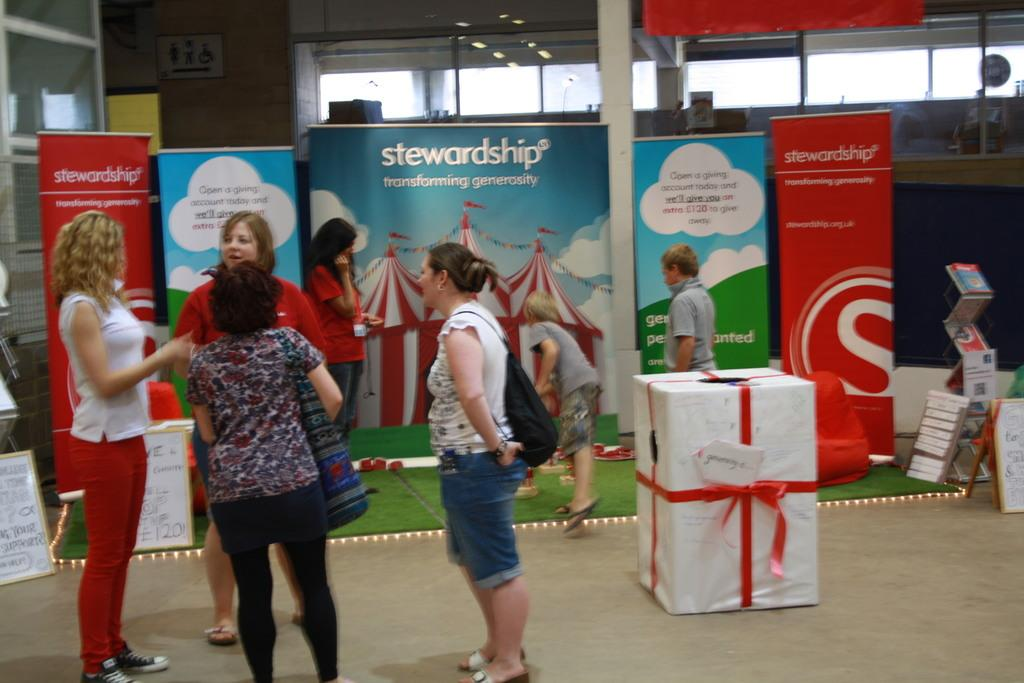<image>
Describe the image concisely. several women and children standing in front of a large "stewardship" advertisement. 